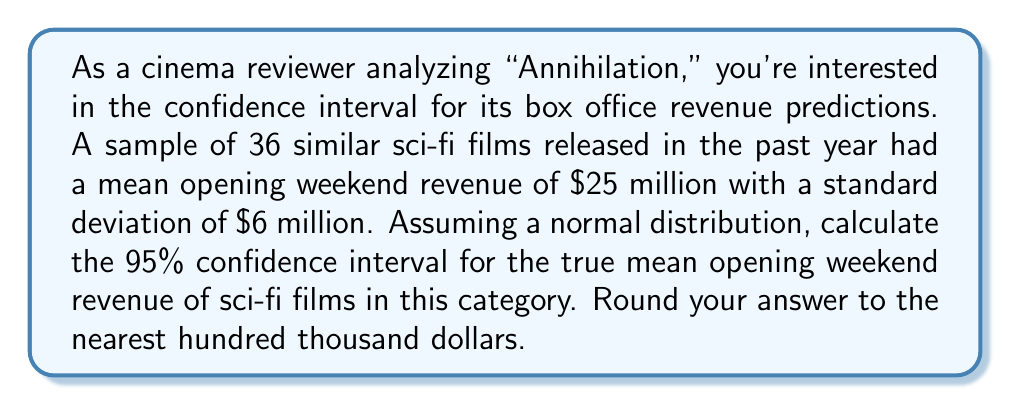Teach me how to tackle this problem. To calculate the confidence interval, we'll follow these steps:

1) The formula for a confidence interval is:

   $$\bar{x} \pm z_{\alpha/2} \cdot \frac{\sigma}{\sqrt{n}}$$

   Where:
   $\bar{x}$ is the sample mean
   $z_{\alpha/2}$ is the critical value
   $\sigma$ is the population standard deviation
   $n$ is the sample size

2) We know:
   $\bar{x} = 25$ million
   $\sigma = 6$ million
   $n = 36$
   For a 95% confidence interval, $z_{\alpha/2} = 1.96$

3) Plugging in the values:

   $$25 \pm 1.96 \cdot \frac{6}{\sqrt{36}}$$

4) Simplify:
   $$25 \pm 1.96 \cdot \frac{6}{6} = 25 \pm 1.96$$

5) Calculate:
   $$25 \pm 1.96 = (23.04, 26.96)$$

6) Rounding to the nearest hundred thousand:
   $$(23.0 \text{ million}, 27.0 \text{ million})$$
Answer: ($23.0 million, $27.0 million) 